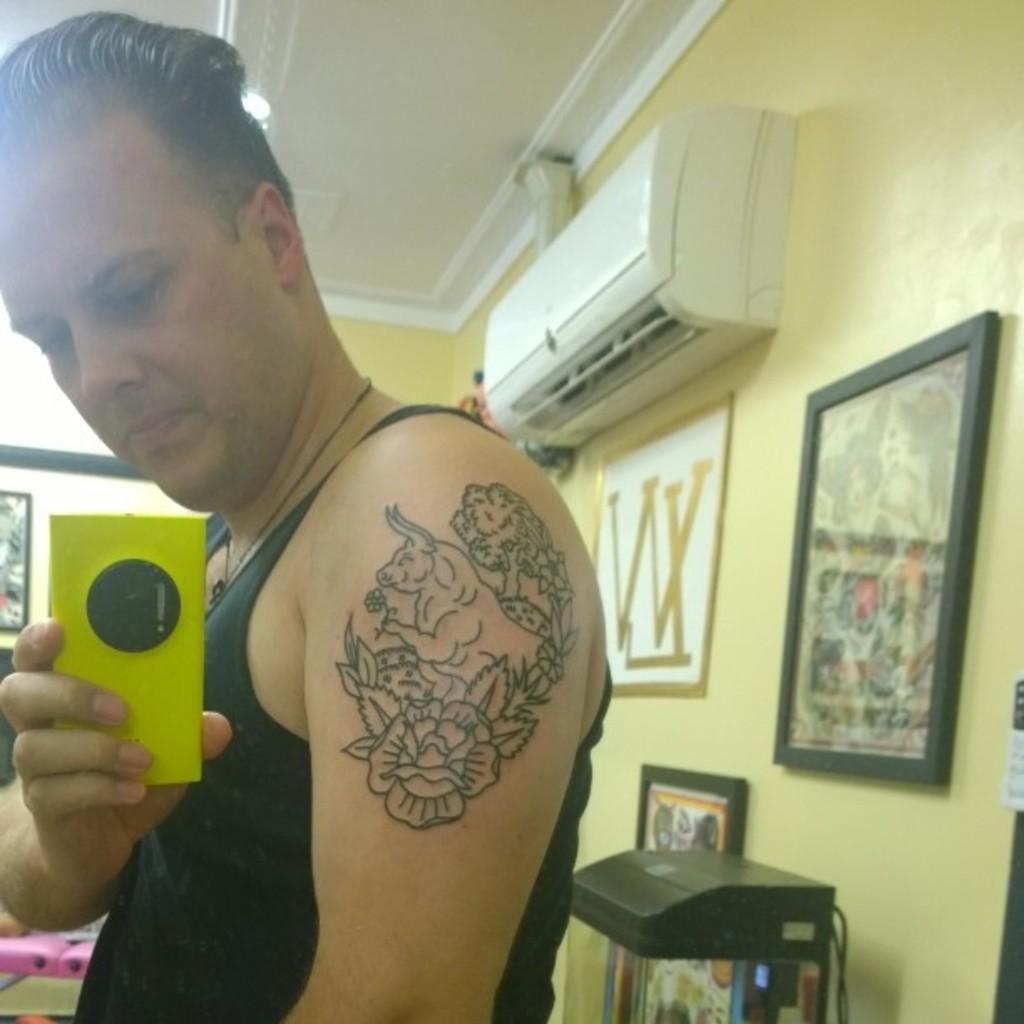What is the man in the image doing? The man is taking a photo with a yellow phone. Can you describe the phone the man is using? The phone is yellow. What is the man showing in the image? The man is showing a tattoo. What color is the wall in the background? The wall in the background is yellow. What can be seen on the wall besides the yellow wall? There are multiple photo frames and an AC unit on the wall. Can you tell me how many grapes are hanging from the AC unit in the image? There are no grapes present in the image; the AC unit is on the wall without any grapes hanging from it. 